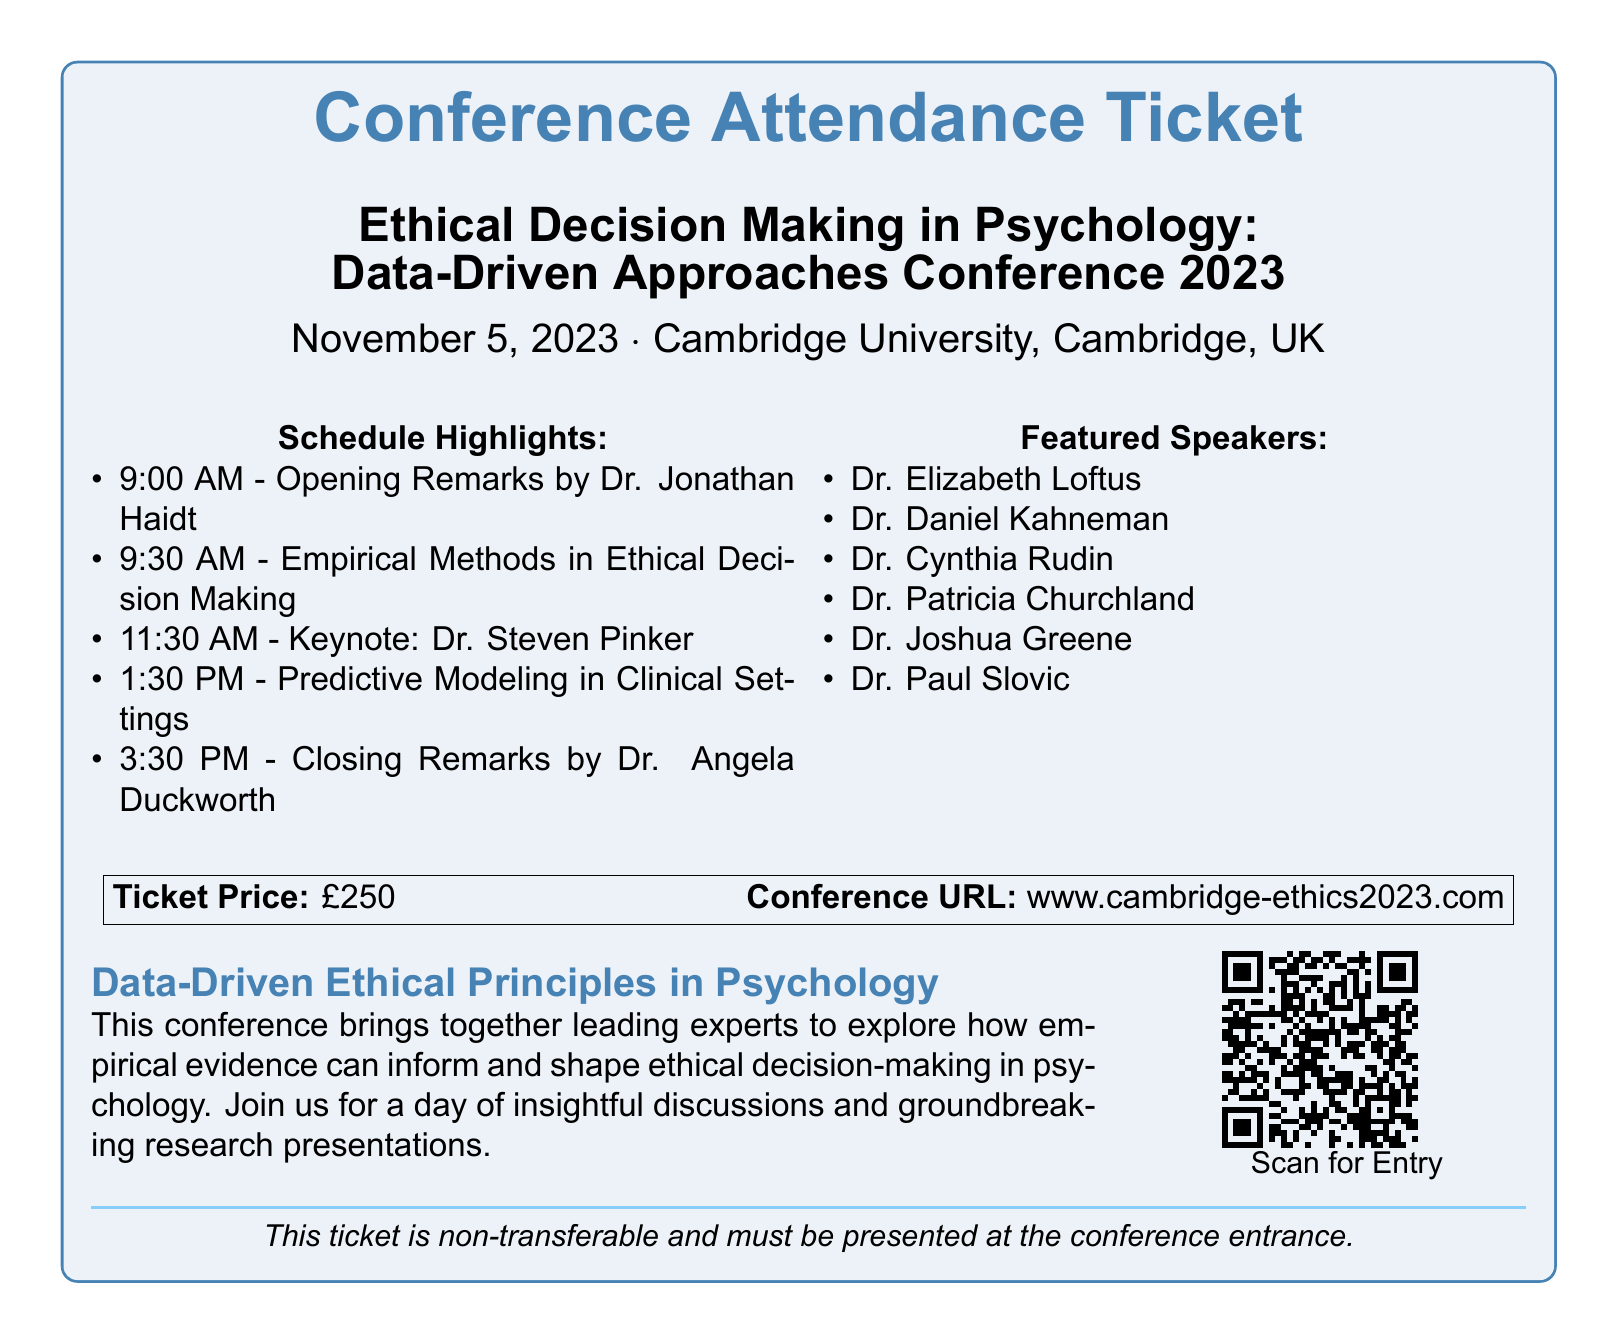What is the title of the conference? The title of the conference is stated in the document under "Ethical Decision Making in Psychology", indicating the focus on data-driven approaches.
Answer: Ethical Decision Making in Psychology: Data-Driven Approaches Conference 2023 What is the date of the conference? The date is prominently mentioned in the header section of the ticket.
Answer: November 5, 2023 Who is giving the keynote speech? The keynote speaker is highlighted in the "Schedule Highlights" section, indicating their role in the conference.
Answer: Dr. Steven Pinker What is the ticket price? The ticket price is specified in the box at the bottom of the document.
Answer: £250 Who is giving the opening remarks? The individual providing opening remarks is named in the schedule, indicating their contribution to the conference.
Answer: Dr. Jonathan Haidt How many featured speakers are listed? The document contains a list of featured speakers that can be counted for this information.
Answer: Six What type of principles does the conference focus on? The conference description mentions the type of principles being discussed, linking it to its empirical basis.
Answer: Data-Driven Ethical Principles What is the URL for the conference? The conference URL is explicitly provided in the box at the bottom of the document.
Answer: www.cambridge-ethics2023.com What should you do with the QR code? The document instructs attendees on the action required with the QR code, supporting entry to the event.
Answer: Scan for Entry 